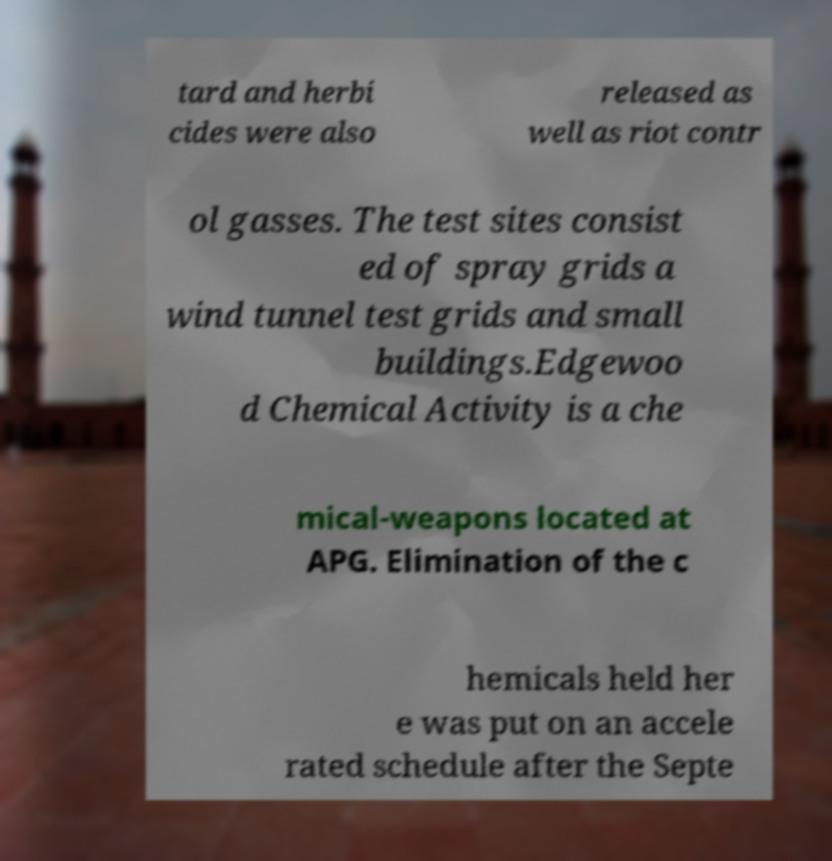Could you extract and type out the text from this image? tard and herbi cides were also released as well as riot contr ol gasses. The test sites consist ed of spray grids a wind tunnel test grids and small buildings.Edgewoo d Chemical Activity is a che mical-weapons located at APG. Elimination of the c hemicals held her e was put on an accele rated schedule after the Septe 